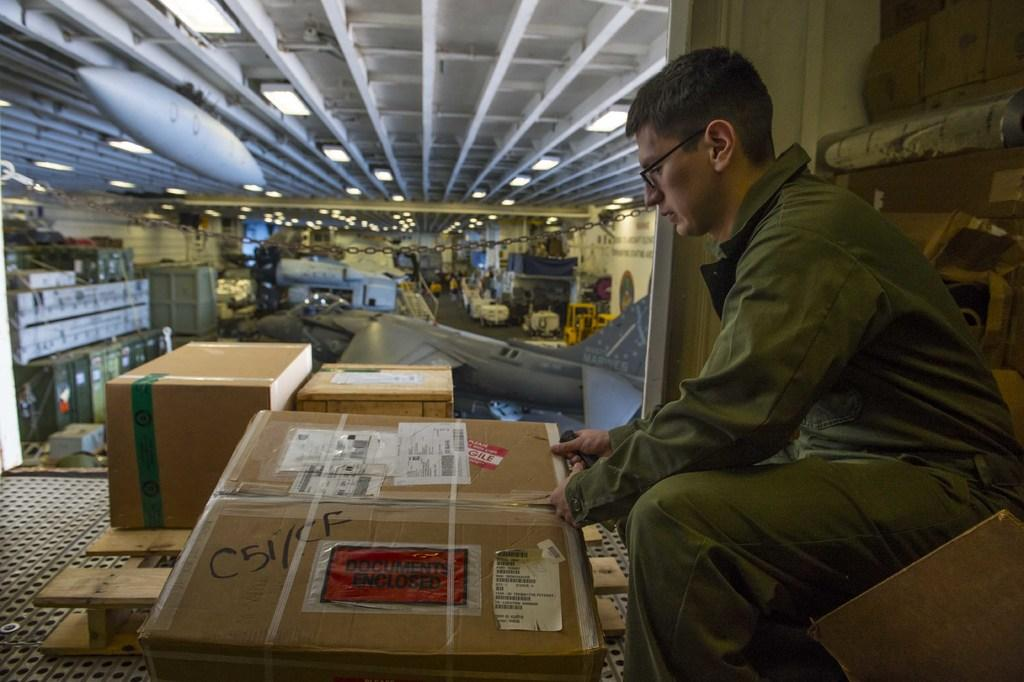<image>
Offer a succinct explanation of the picture presented. A man is opening a box that has C51/CF written in black marker on it. 